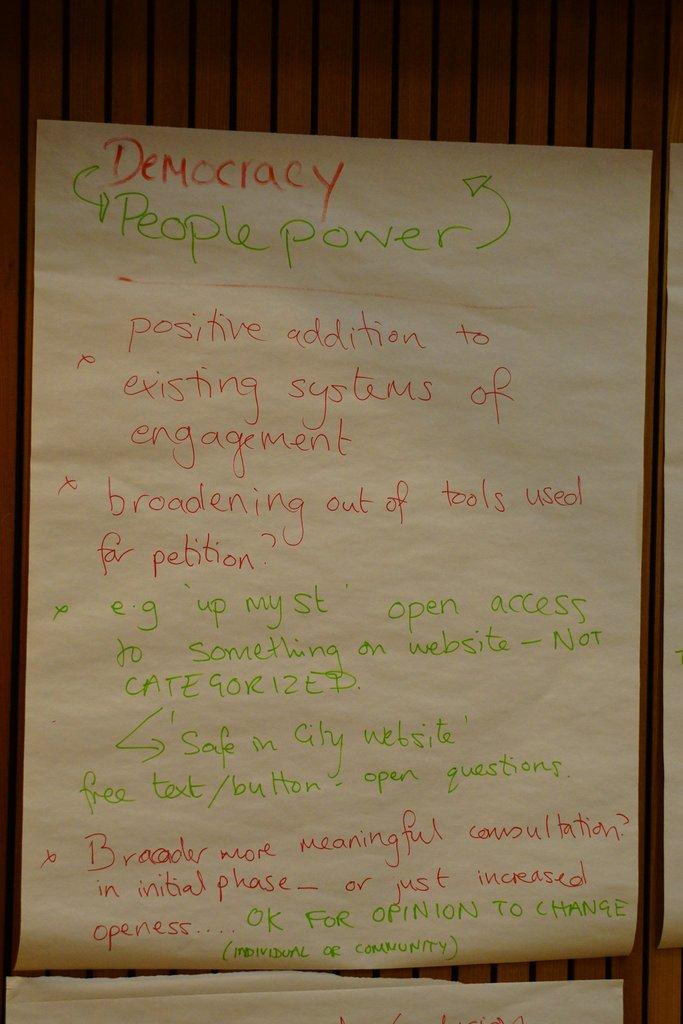Provide a one-sentence caption for the provided image. A paper has hand written notes on it that says Democracy People Power. 